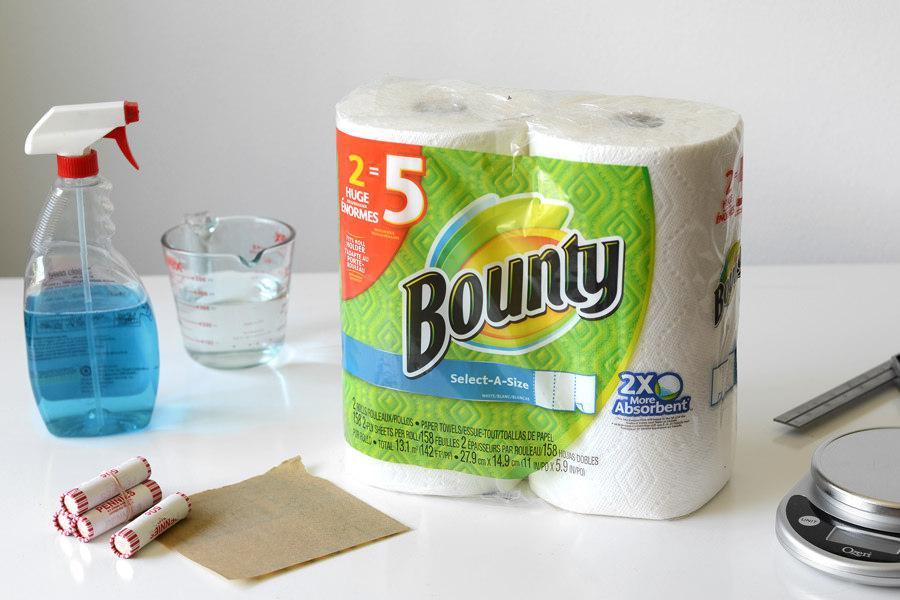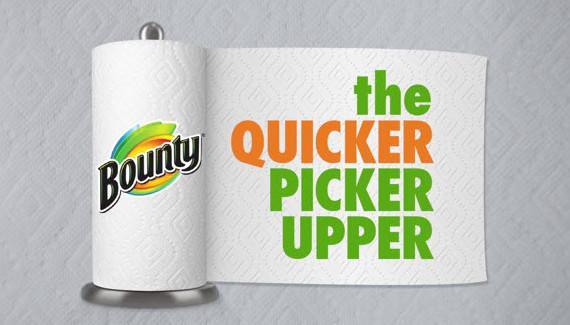The first image is the image on the left, the second image is the image on the right. Analyze the images presented: Is the assertion "There is a single roll of bounty that is in a green place with the bounty label." valid? Answer yes or no. No. 